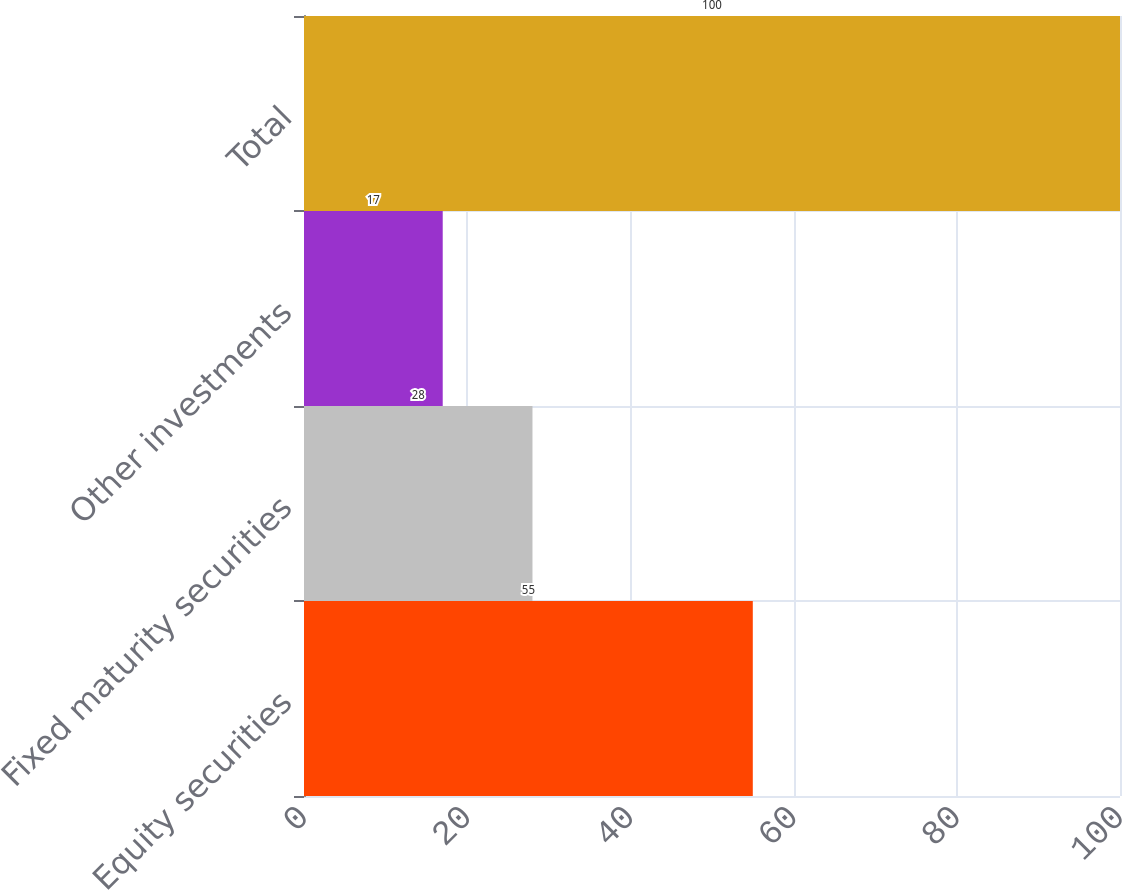Convert chart to OTSL. <chart><loc_0><loc_0><loc_500><loc_500><bar_chart><fcel>Equity securities<fcel>Fixed maturity securities<fcel>Other investments<fcel>Total<nl><fcel>55<fcel>28<fcel>17<fcel>100<nl></chart> 